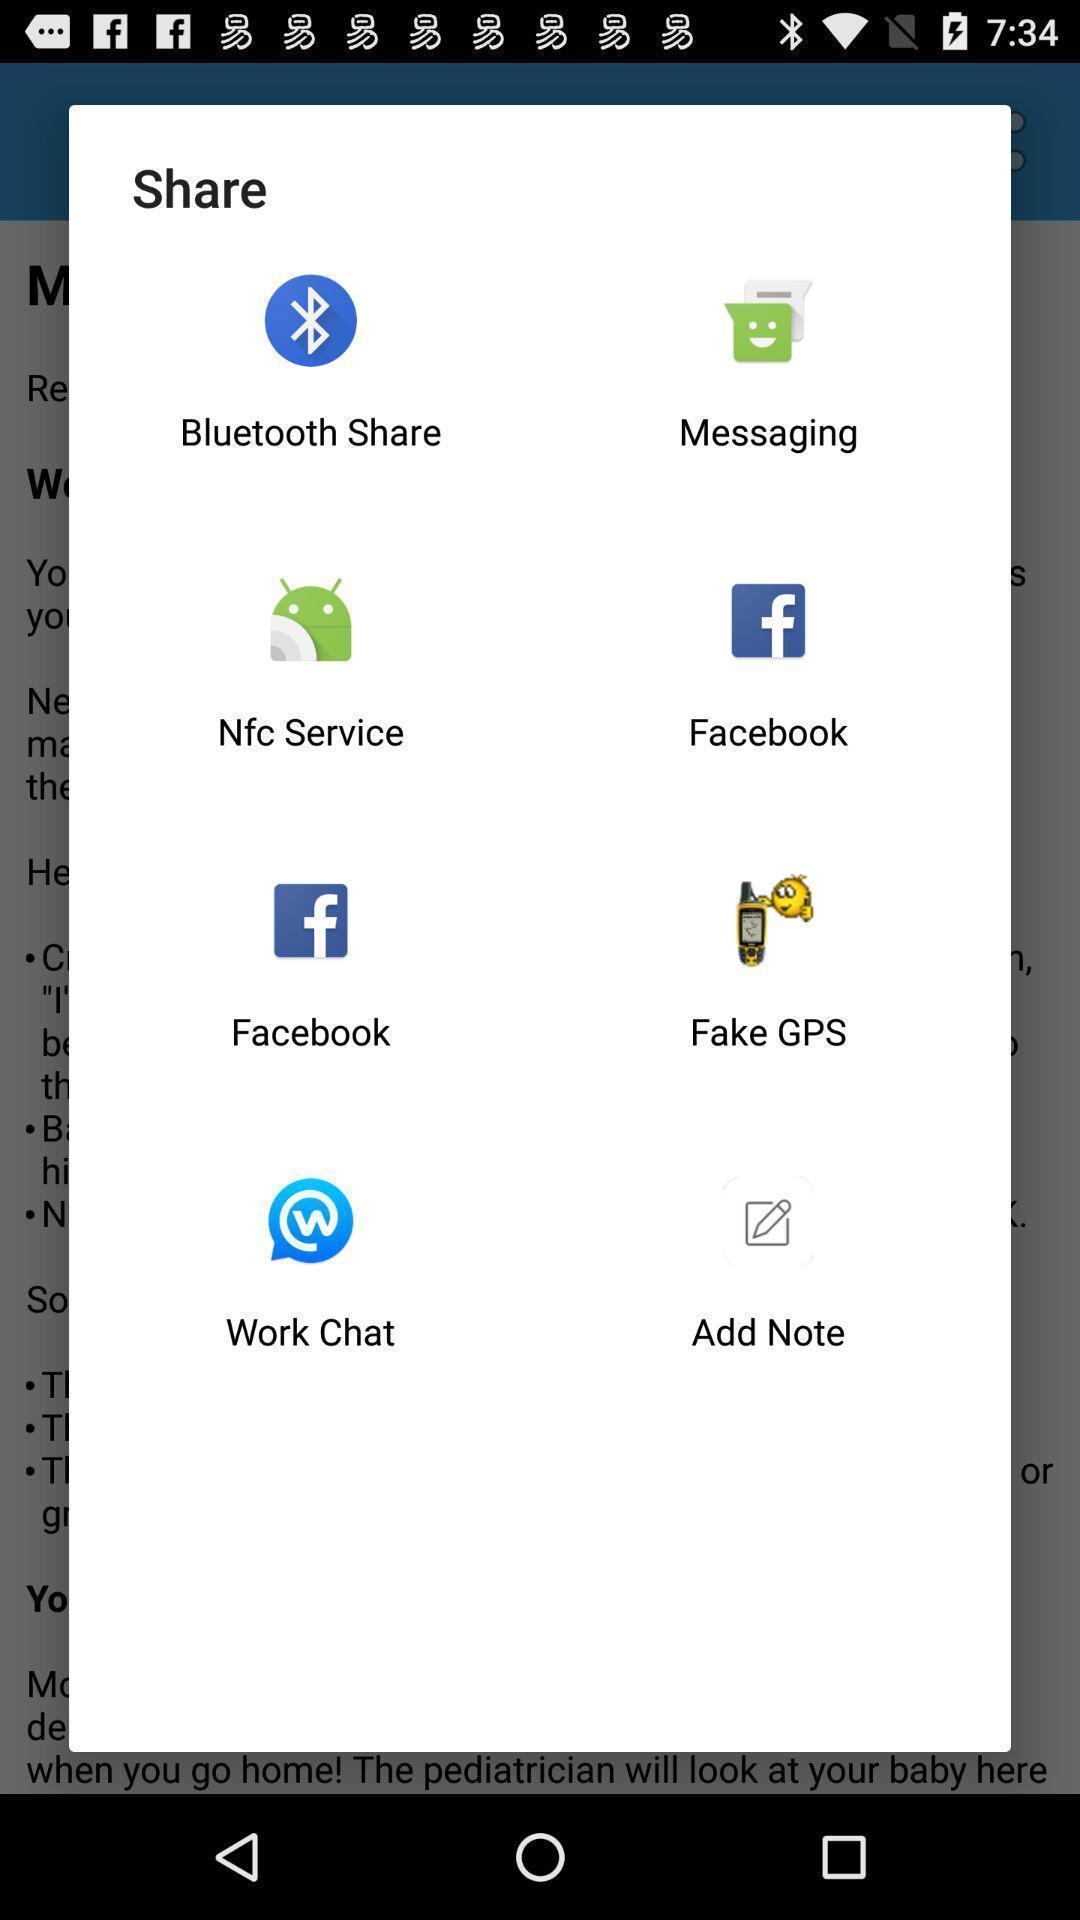Summarize the main components in this picture. Pop-up to share through various applications. 